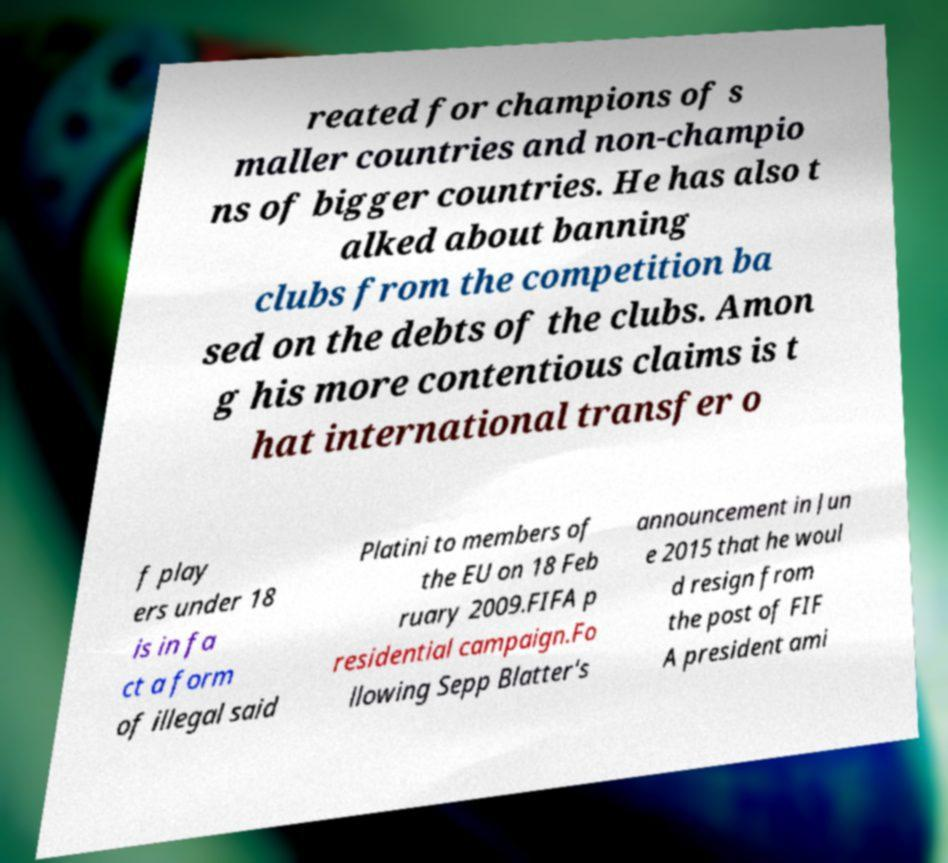Could you assist in decoding the text presented in this image and type it out clearly? reated for champions of s maller countries and non-champio ns of bigger countries. He has also t alked about banning clubs from the competition ba sed on the debts of the clubs. Amon g his more contentious claims is t hat international transfer o f play ers under 18 is in fa ct a form of illegal said Platini to members of the EU on 18 Feb ruary 2009.FIFA p residential campaign.Fo llowing Sepp Blatter's announcement in Jun e 2015 that he woul d resign from the post of FIF A president ami 